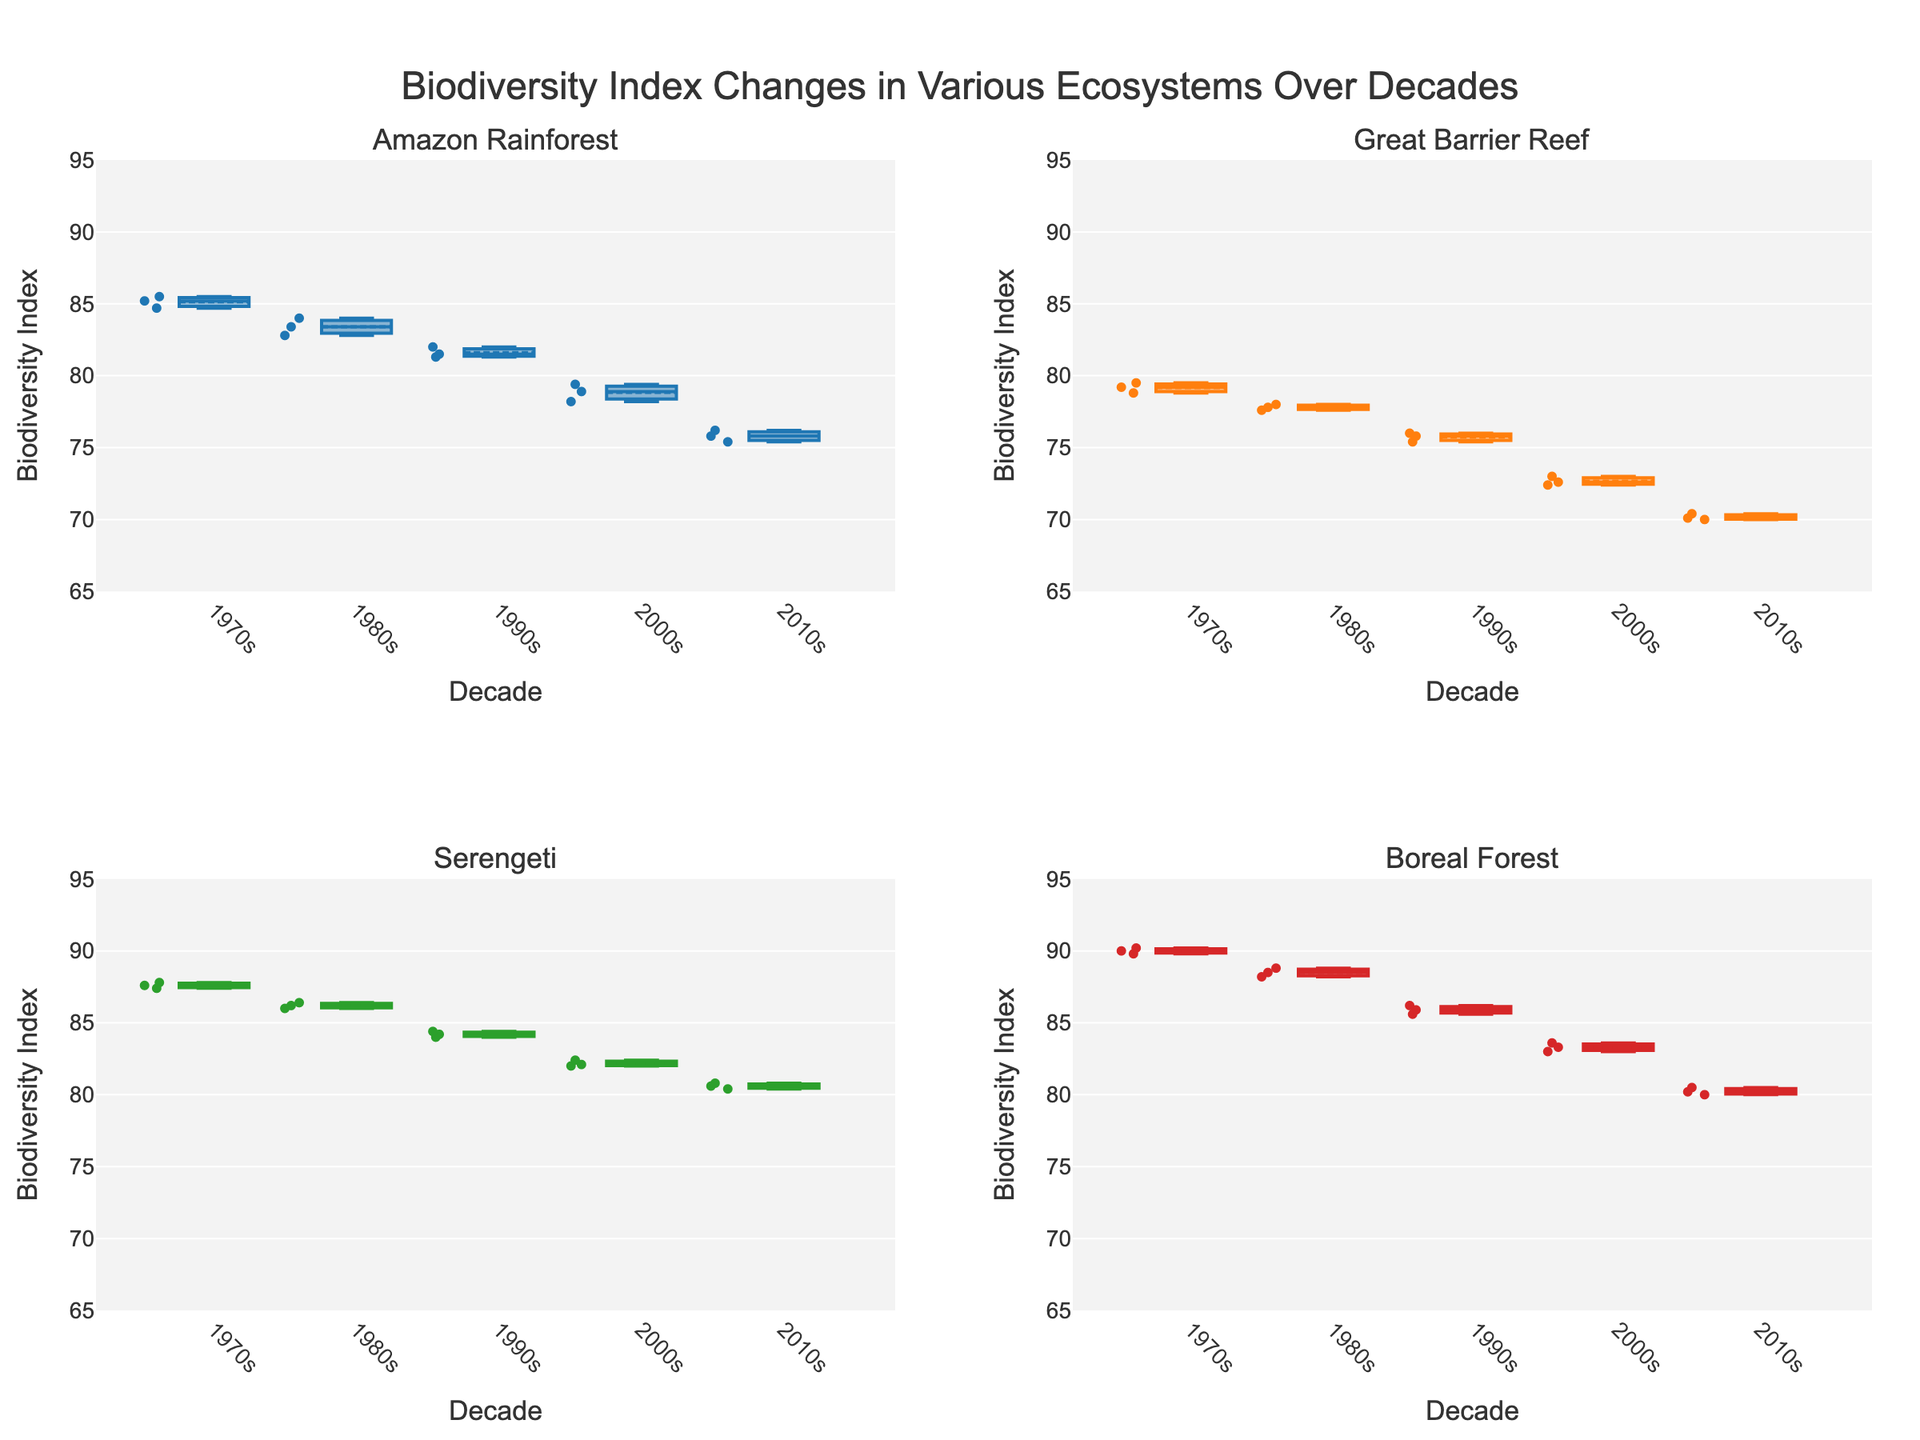How many ecosystems are visualized in the box plot figure? The figure is divided into 4 subplots, each representing a different ecosystem. Look at the subplot titles to count them.
Answer: 4 What is the title of the figure? The title is prominently displayed at the top of the figure and summarizes the overall theme.
Answer: Biodiversity Index Changes in Various Ecosystems Over Decades Which ecosystem has the highest median Biodiversity Index in the 1970s? Check the central line of the boxes representing the 1970s across all subplots. The highest median value will be the highest central line.
Answer: Boreal Forest Did the Amazon Rainforest show an increase or decrease in the Biodiversity Index from the 1970s to the 2010s? Track the median line or summarize trend line in the box plots for the Amazon Rainforest from the 1970s to the 2010s.
Answer: Decrease In which decade do the box plots for the Great Barrier Reef show the largest spread (range) in Biodiversity Index? The largest spread in a box plot is indicated by the longest box. Look at the length of the boxes for each decade in the Great Barrier Reef subplot.
Answer: 1970s How does the Biodiversity Index of the Serengeti in the 2010s compare to the Amazon Rainforest in the 2010s? Compare the central lines of the boxes in the Serengeti and Amazon Rainforest subplots for the 2010s. Determine which is higher or if they are equal.
Answer: Serengeti is higher What is the trend observed in the Biodiversity Index of the Boreal Forest from the 1970s to the 2010s? Note the median values and the general movement of the box plots for the Boreal Forest across the decades.
Answer: Decreasing trend Compare the interquartile range (IQR) of the Biodiversity Index for the Boreal Forest in the 1980s and 2000s. Which is greater? The IQR is represented by the height of the box from the first quartile to the third quartile. Compare these heights for the Boreal Forest in the 1980s and 2000s.
Answer: 1980s Which ecosystem had the least variability in Biodiversity Index during the 1990s? Variability in the box plot is indicated by the size of the box and the placement of the points. The ecosystem with the smallest box plot in the 1990s would have the least variability.
Answer: Serengeti What can be inferred about the overall trend of Biodiversity Index across all ecosystems from the 1970s to the 2010s? Assess the general direction of the medians and the boxes from the 1970s to the 2010s across all ecosystems. Look for common trends.
Answer: Decreasing trend across all ecosystems 